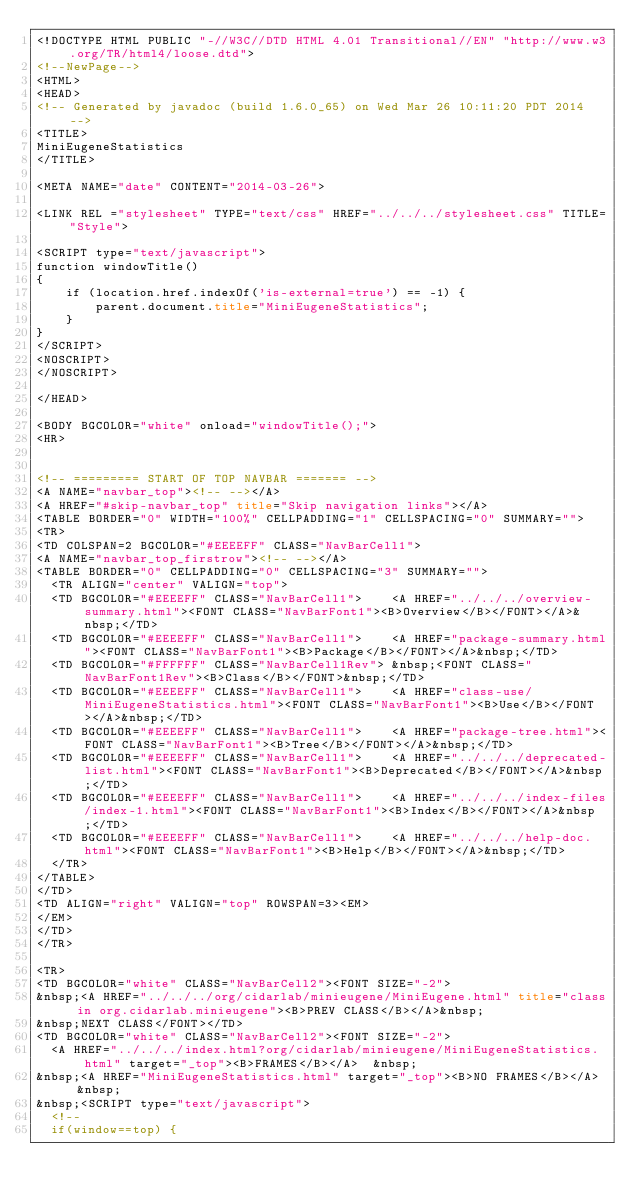Convert code to text. <code><loc_0><loc_0><loc_500><loc_500><_HTML_><!DOCTYPE HTML PUBLIC "-//W3C//DTD HTML 4.01 Transitional//EN" "http://www.w3.org/TR/html4/loose.dtd">
<!--NewPage-->
<HTML>
<HEAD>
<!-- Generated by javadoc (build 1.6.0_65) on Wed Mar 26 10:11:20 PDT 2014 -->
<TITLE>
MiniEugeneStatistics
</TITLE>

<META NAME="date" CONTENT="2014-03-26">

<LINK REL ="stylesheet" TYPE="text/css" HREF="../../../stylesheet.css" TITLE="Style">

<SCRIPT type="text/javascript">
function windowTitle()
{
    if (location.href.indexOf('is-external=true') == -1) {
        parent.document.title="MiniEugeneStatistics";
    }
}
</SCRIPT>
<NOSCRIPT>
</NOSCRIPT>

</HEAD>

<BODY BGCOLOR="white" onload="windowTitle();">
<HR>


<!-- ========= START OF TOP NAVBAR ======= -->
<A NAME="navbar_top"><!-- --></A>
<A HREF="#skip-navbar_top" title="Skip navigation links"></A>
<TABLE BORDER="0" WIDTH="100%" CELLPADDING="1" CELLSPACING="0" SUMMARY="">
<TR>
<TD COLSPAN=2 BGCOLOR="#EEEEFF" CLASS="NavBarCell1">
<A NAME="navbar_top_firstrow"><!-- --></A>
<TABLE BORDER="0" CELLPADDING="0" CELLSPACING="3" SUMMARY="">
  <TR ALIGN="center" VALIGN="top">
  <TD BGCOLOR="#EEEEFF" CLASS="NavBarCell1">    <A HREF="../../../overview-summary.html"><FONT CLASS="NavBarFont1"><B>Overview</B></FONT></A>&nbsp;</TD>
  <TD BGCOLOR="#EEEEFF" CLASS="NavBarCell1">    <A HREF="package-summary.html"><FONT CLASS="NavBarFont1"><B>Package</B></FONT></A>&nbsp;</TD>
  <TD BGCOLOR="#FFFFFF" CLASS="NavBarCell1Rev"> &nbsp;<FONT CLASS="NavBarFont1Rev"><B>Class</B></FONT>&nbsp;</TD>
  <TD BGCOLOR="#EEEEFF" CLASS="NavBarCell1">    <A HREF="class-use/MiniEugeneStatistics.html"><FONT CLASS="NavBarFont1"><B>Use</B></FONT></A>&nbsp;</TD>
  <TD BGCOLOR="#EEEEFF" CLASS="NavBarCell1">    <A HREF="package-tree.html"><FONT CLASS="NavBarFont1"><B>Tree</B></FONT></A>&nbsp;</TD>
  <TD BGCOLOR="#EEEEFF" CLASS="NavBarCell1">    <A HREF="../../../deprecated-list.html"><FONT CLASS="NavBarFont1"><B>Deprecated</B></FONT></A>&nbsp;</TD>
  <TD BGCOLOR="#EEEEFF" CLASS="NavBarCell1">    <A HREF="../../../index-files/index-1.html"><FONT CLASS="NavBarFont1"><B>Index</B></FONT></A>&nbsp;</TD>
  <TD BGCOLOR="#EEEEFF" CLASS="NavBarCell1">    <A HREF="../../../help-doc.html"><FONT CLASS="NavBarFont1"><B>Help</B></FONT></A>&nbsp;</TD>
  </TR>
</TABLE>
</TD>
<TD ALIGN="right" VALIGN="top" ROWSPAN=3><EM>
</EM>
</TD>
</TR>

<TR>
<TD BGCOLOR="white" CLASS="NavBarCell2"><FONT SIZE="-2">
&nbsp;<A HREF="../../../org/cidarlab/minieugene/MiniEugene.html" title="class in org.cidarlab.minieugene"><B>PREV CLASS</B></A>&nbsp;
&nbsp;NEXT CLASS</FONT></TD>
<TD BGCOLOR="white" CLASS="NavBarCell2"><FONT SIZE="-2">
  <A HREF="../../../index.html?org/cidarlab/minieugene/MiniEugeneStatistics.html" target="_top"><B>FRAMES</B></A>  &nbsp;
&nbsp;<A HREF="MiniEugeneStatistics.html" target="_top"><B>NO FRAMES</B></A>  &nbsp;
&nbsp;<SCRIPT type="text/javascript">
  <!--
  if(window==top) {</code> 